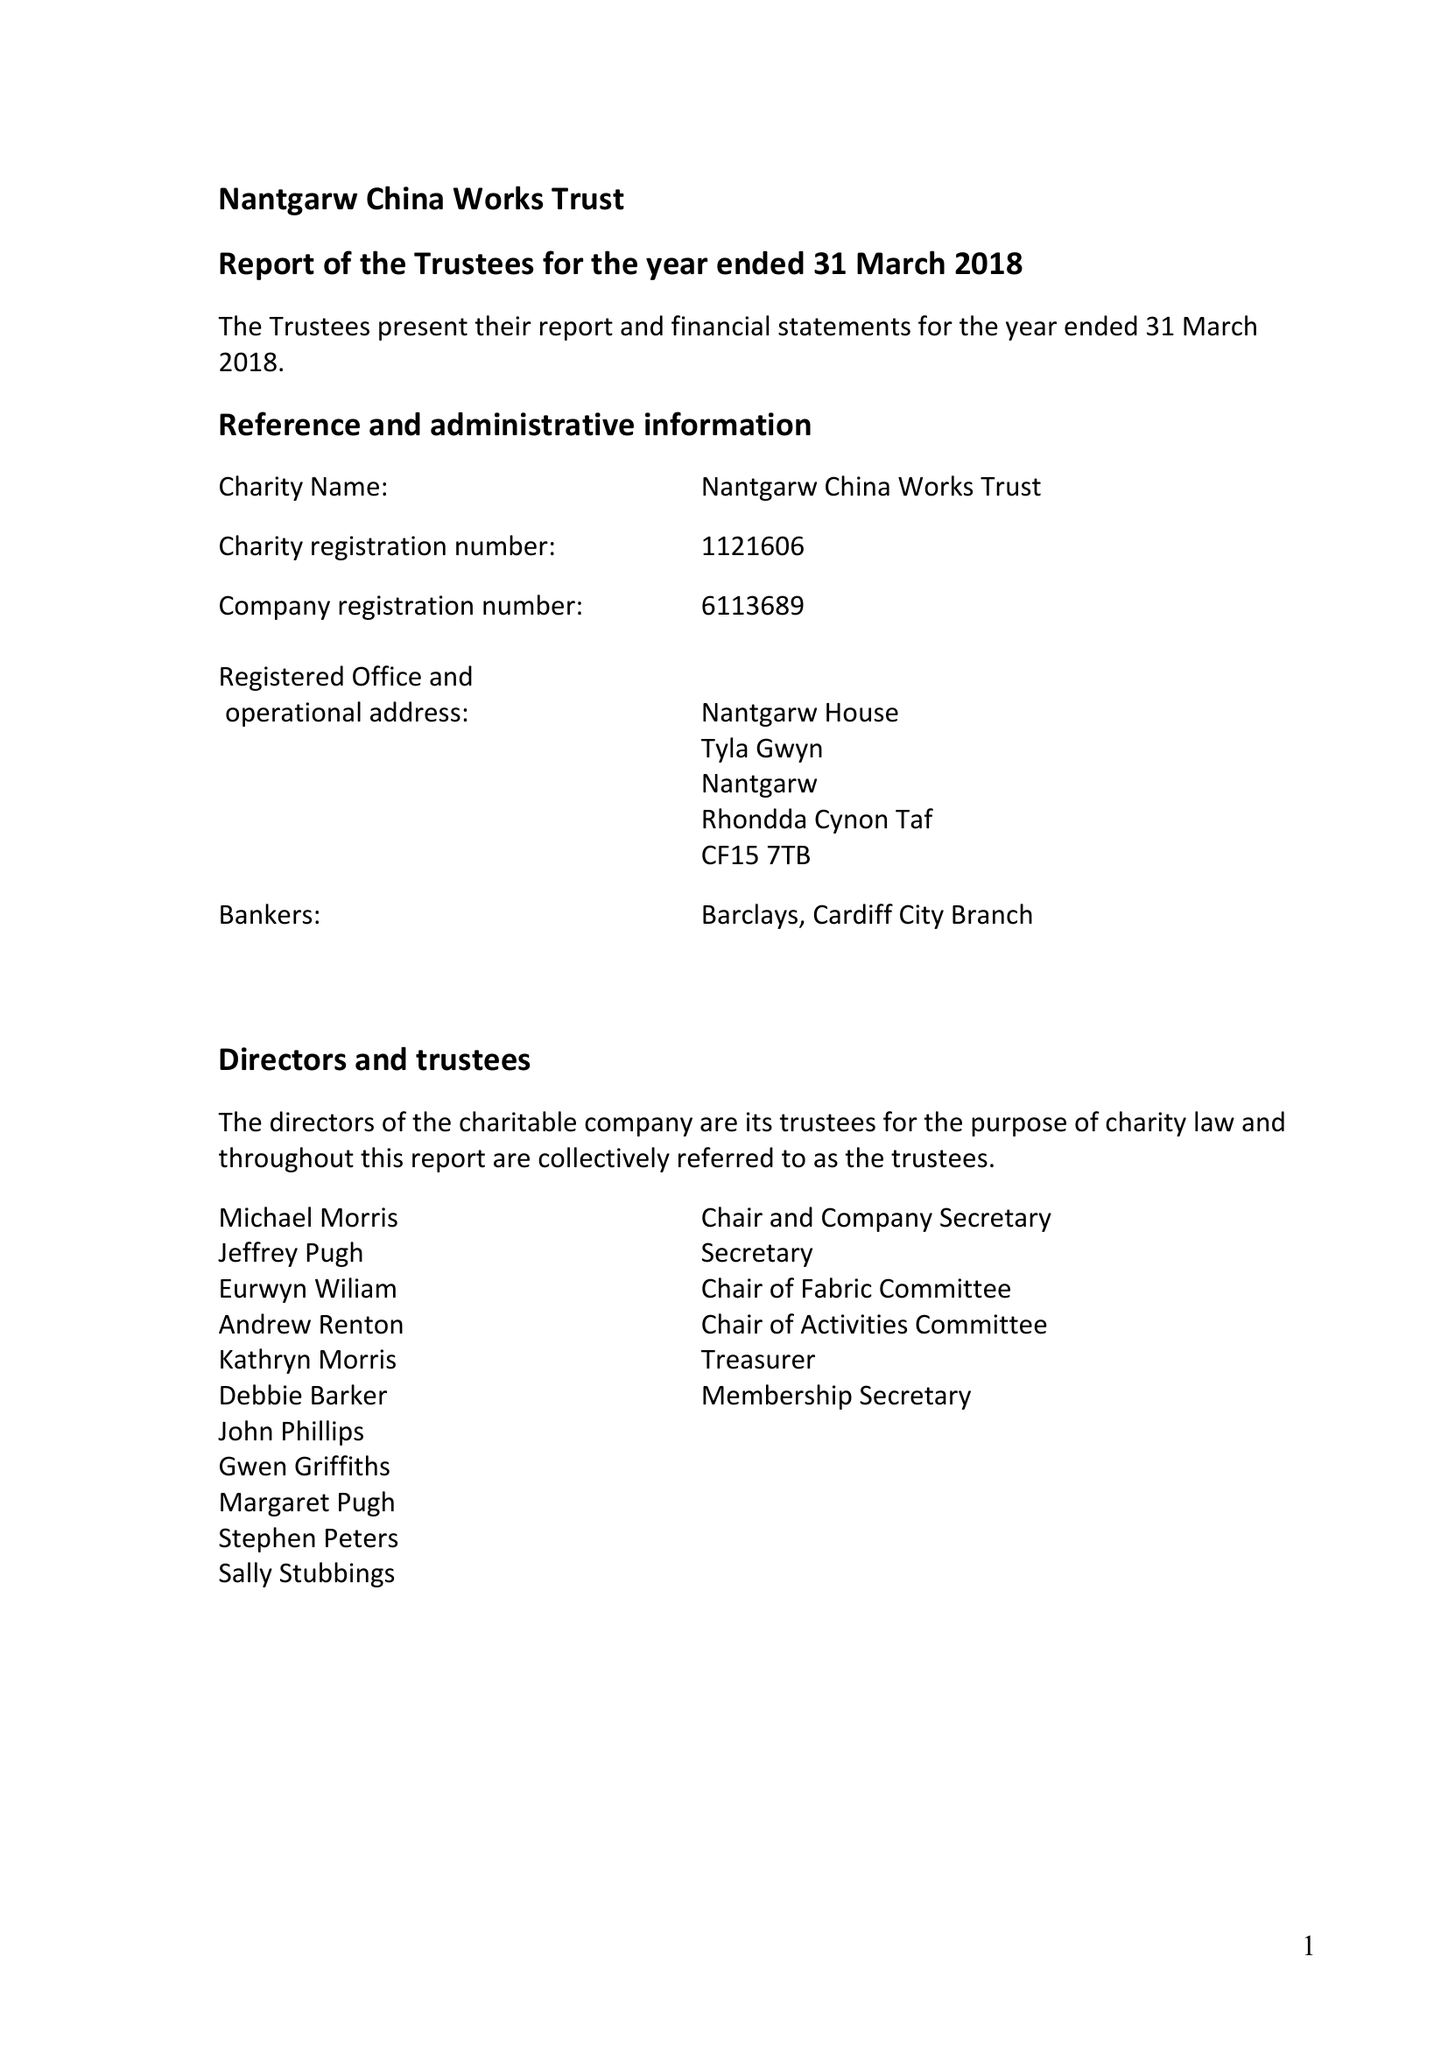What is the value for the income_annually_in_british_pounds?
Answer the question using a single word or phrase. 42207.00 